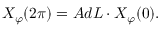<formula> <loc_0><loc_0><loc_500><loc_500>X _ { \varphi } ( 2 \pi ) = A d L \cdot X _ { \varphi } ( 0 ) .</formula> 